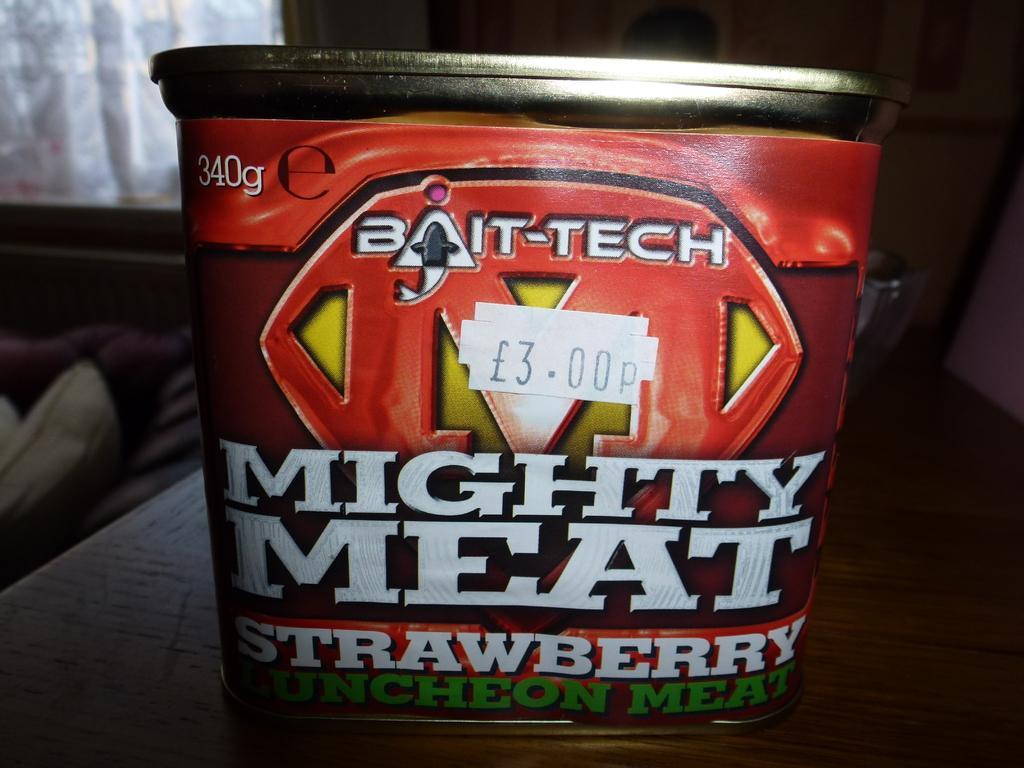Please provide a concise description of this image. This image is taken indoors. In the background there is a wall and there is a window. At the bottom of the image there is a table with a box on it. There is a text on the box. On the left side of the image there are a few objects. 